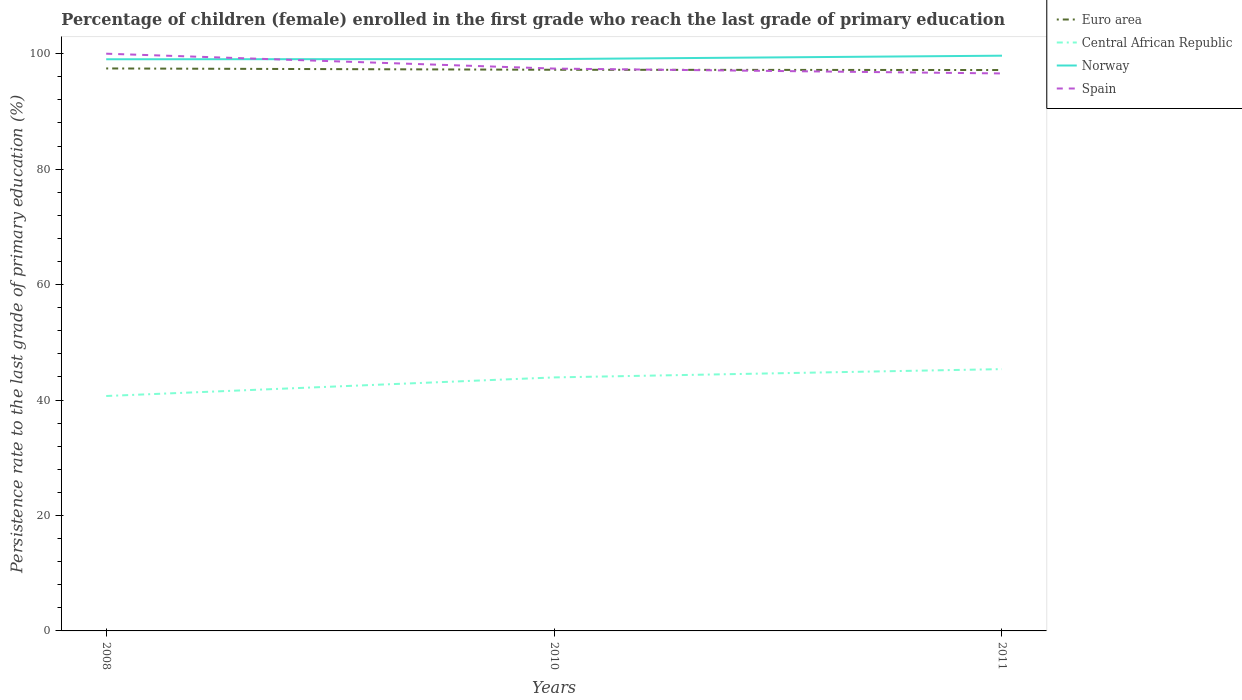How many different coloured lines are there?
Offer a terse response. 4. Across all years, what is the maximum persistence rate of children in Central African Republic?
Offer a terse response. 40.7. What is the total persistence rate of children in Spain in the graph?
Your response must be concise. 2.58. What is the difference between the highest and the second highest persistence rate of children in Norway?
Make the answer very short. 0.62. What is the difference between the highest and the lowest persistence rate of children in Spain?
Make the answer very short. 1. How many years are there in the graph?
Give a very brief answer. 3. What is the difference between two consecutive major ticks on the Y-axis?
Provide a short and direct response. 20. Does the graph contain any zero values?
Keep it short and to the point. No. Does the graph contain grids?
Offer a terse response. No. What is the title of the graph?
Give a very brief answer. Percentage of children (female) enrolled in the first grade who reach the last grade of primary education. What is the label or title of the Y-axis?
Make the answer very short. Persistence rate to the last grade of primary education (%). What is the Persistence rate to the last grade of primary education (%) in Euro area in 2008?
Your answer should be very brief. 97.44. What is the Persistence rate to the last grade of primary education (%) of Central African Republic in 2008?
Offer a terse response. 40.7. What is the Persistence rate to the last grade of primary education (%) of Norway in 2008?
Offer a terse response. 99.03. What is the Persistence rate to the last grade of primary education (%) in Spain in 2008?
Keep it short and to the point. 100. What is the Persistence rate to the last grade of primary education (%) in Euro area in 2010?
Keep it short and to the point. 97.21. What is the Persistence rate to the last grade of primary education (%) in Central African Republic in 2010?
Provide a short and direct response. 43.92. What is the Persistence rate to the last grade of primary education (%) in Norway in 2010?
Give a very brief answer. 99.07. What is the Persistence rate to the last grade of primary education (%) in Spain in 2010?
Give a very brief answer. 97.42. What is the Persistence rate to the last grade of primary education (%) of Euro area in 2011?
Your answer should be very brief. 97.17. What is the Persistence rate to the last grade of primary education (%) in Central African Republic in 2011?
Provide a succinct answer. 45.35. What is the Persistence rate to the last grade of primary education (%) in Norway in 2011?
Your answer should be very brief. 99.65. What is the Persistence rate to the last grade of primary education (%) in Spain in 2011?
Your answer should be very brief. 96.57. Across all years, what is the maximum Persistence rate to the last grade of primary education (%) in Euro area?
Keep it short and to the point. 97.44. Across all years, what is the maximum Persistence rate to the last grade of primary education (%) of Central African Republic?
Your answer should be very brief. 45.35. Across all years, what is the maximum Persistence rate to the last grade of primary education (%) in Norway?
Ensure brevity in your answer.  99.65. Across all years, what is the maximum Persistence rate to the last grade of primary education (%) of Spain?
Ensure brevity in your answer.  100. Across all years, what is the minimum Persistence rate to the last grade of primary education (%) of Euro area?
Ensure brevity in your answer.  97.17. Across all years, what is the minimum Persistence rate to the last grade of primary education (%) in Central African Republic?
Provide a succinct answer. 40.7. Across all years, what is the minimum Persistence rate to the last grade of primary education (%) of Norway?
Offer a very short reply. 99.03. Across all years, what is the minimum Persistence rate to the last grade of primary education (%) in Spain?
Offer a very short reply. 96.57. What is the total Persistence rate to the last grade of primary education (%) in Euro area in the graph?
Ensure brevity in your answer.  291.82. What is the total Persistence rate to the last grade of primary education (%) of Central African Republic in the graph?
Your response must be concise. 129.97. What is the total Persistence rate to the last grade of primary education (%) in Norway in the graph?
Your answer should be very brief. 297.75. What is the total Persistence rate to the last grade of primary education (%) in Spain in the graph?
Make the answer very short. 293.99. What is the difference between the Persistence rate to the last grade of primary education (%) in Euro area in 2008 and that in 2010?
Ensure brevity in your answer.  0.23. What is the difference between the Persistence rate to the last grade of primary education (%) in Central African Republic in 2008 and that in 2010?
Offer a very short reply. -3.22. What is the difference between the Persistence rate to the last grade of primary education (%) of Norway in 2008 and that in 2010?
Offer a terse response. -0.04. What is the difference between the Persistence rate to the last grade of primary education (%) of Spain in 2008 and that in 2010?
Give a very brief answer. 2.58. What is the difference between the Persistence rate to the last grade of primary education (%) of Euro area in 2008 and that in 2011?
Your answer should be very brief. 0.27. What is the difference between the Persistence rate to the last grade of primary education (%) in Central African Republic in 2008 and that in 2011?
Your answer should be compact. -4.66. What is the difference between the Persistence rate to the last grade of primary education (%) in Norway in 2008 and that in 2011?
Your response must be concise. -0.62. What is the difference between the Persistence rate to the last grade of primary education (%) of Spain in 2008 and that in 2011?
Offer a very short reply. 3.42. What is the difference between the Persistence rate to the last grade of primary education (%) in Euro area in 2010 and that in 2011?
Make the answer very short. 0.05. What is the difference between the Persistence rate to the last grade of primary education (%) of Central African Republic in 2010 and that in 2011?
Provide a short and direct response. -1.44. What is the difference between the Persistence rate to the last grade of primary education (%) in Norway in 2010 and that in 2011?
Your answer should be very brief. -0.58. What is the difference between the Persistence rate to the last grade of primary education (%) of Spain in 2010 and that in 2011?
Give a very brief answer. 0.84. What is the difference between the Persistence rate to the last grade of primary education (%) of Euro area in 2008 and the Persistence rate to the last grade of primary education (%) of Central African Republic in 2010?
Give a very brief answer. 53.52. What is the difference between the Persistence rate to the last grade of primary education (%) of Euro area in 2008 and the Persistence rate to the last grade of primary education (%) of Norway in 2010?
Ensure brevity in your answer.  -1.63. What is the difference between the Persistence rate to the last grade of primary education (%) of Euro area in 2008 and the Persistence rate to the last grade of primary education (%) of Spain in 2010?
Your answer should be very brief. 0.02. What is the difference between the Persistence rate to the last grade of primary education (%) of Central African Republic in 2008 and the Persistence rate to the last grade of primary education (%) of Norway in 2010?
Your answer should be compact. -58.37. What is the difference between the Persistence rate to the last grade of primary education (%) in Central African Republic in 2008 and the Persistence rate to the last grade of primary education (%) in Spain in 2010?
Keep it short and to the point. -56.72. What is the difference between the Persistence rate to the last grade of primary education (%) in Norway in 2008 and the Persistence rate to the last grade of primary education (%) in Spain in 2010?
Your response must be concise. 1.61. What is the difference between the Persistence rate to the last grade of primary education (%) of Euro area in 2008 and the Persistence rate to the last grade of primary education (%) of Central African Republic in 2011?
Your response must be concise. 52.09. What is the difference between the Persistence rate to the last grade of primary education (%) in Euro area in 2008 and the Persistence rate to the last grade of primary education (%) in Norway in 2011?
Offer a terse response. -2.21. What is the difference between the Persistence rate to the last grade of primary education (%) in Euro area in 2008 and the Persistence rate to the last grade of primary education (%) in Spain in 2011?
Your answer should be very brief. 0.87. What is the difference between the Persistence rate to the last grade of primary education (%) of Central African Republic in 2008 and the Persistence rate to the last grade of primary education (%) of Norway in 2011?
Ensure brevity in your answer.  -58.96. What is the difference between the Persistence rate to the last grade of primary education (%) of Central African Republic in 2008 and the Persistence rate to the last grade of primary education (%) of Spain in 2011?
Ensure brevity in your answer.  -55.88. What is the difference between the Persistence rate to the last grade of primary education (%) of Norway in 2008 and the Persistence rate to the last grade of primary education (%) of Spain in 2011?
Give a very brief answer. 2.46. What is the difference between the Persistence rate to the last grade of primary education (%) of Euro area in 2010 and the Persistence rate to the last grade of primary education (%) of Central African Republic in 2011?
Offer a terse response. 51.86. What is the difference between the Persistence rate to the last grade of primary education (%) in Euro area in 2010 and the Persistence rate to the last grade of primary education (%) in Norway in 2011?
Ensure brevity in your answer.  -2.44. What is the difference between the Persistence rate to the last grade of primary education (%) of Euro area in 2010 and the Persistence rate to the last grade of primary education (%) of Spain in 2011?
Keep it short and to the point. 0.64. What is the difference between the Persistence rate to the last grade of primary education (%) of Central African Republic in 2010 and the Persistence rate to the last grade of primary education (%) of Norway in 2011?
Provide a short and direct response. -55.73. What is the difference between the Persistence rate to the last grade of primary education (%) of Central African Republic in 2010 and the Persistence rate to the last grade of primary education (%) of Spain in 2011?
Provide a succinct answer. -52.66. What is the difference between the Persistence rate to the last grade of primary education (%) of Norway in 2010 and the Persistence rate to the last grade of primary education (%) of Spain in 2011?
Give a very brief answer. 2.49. What is the average Persistence rate to the last grade of primary education (%) of Euro area per year?
Offer a terse response. 97.27. What is the average Persistence rate to the last grade of primary education (%) in Central African Republic per year?
Offer a very short reply. 43.32. What is the average Persistence rate to the last grade of primary education (%) in Norway per year?
Provide a short and direct response. 99.25. What is the average Persistence rate to the last grade of primary education (%) in Spain per year?
Offer a very short reply. 98. In the year 2008, what is the difference between the Persistence rate to the last grade of primary education (%) in Euro area and Persistence rate to the last grade of primary education (%) in Central African Republic?
Keep it short and to the point. 56.74. In the year 2008, what is the difference between the Persistence rate to the last grade of primary education (%) in Euro area and Persistence rate to the last grade of primary education (%) in Norway?
Your answer should be very brief. -1.59. In the year 2008, what is the difference between the Persistence rate to the last grade of primary education (%) of Euro area and Persistence rate to the last grade of primary education (%) of Spain?
Offer a very short reply. -2.56. In the year 2008, what is the difference between the Persistence rate to the last grade of primary education (%) of Central African Republic and Persistence rate to the last grade of primary education (%) of Norway?
Offer a very short reply. -58.34. In the year 2008, what is the difference between the Persistence rate to the last grade of primary education (%) in Central African Republic and Persistence rate to the last grade of primary education (%) in Spain?
Provide a short and direct response. -59.3. In the year 2008, what is the difference between the Persistence rate to the last grade of primary education (%) of Norway and Persistence rate to the last grade of primary education (%) of Spain?
Your response must be concise. -0.97. In the year 2010, what is the difference between the Persistence rate to the last grade of primary education (%) in Euro area and Persistence rate to the last grade of primary education (%) in Central African Republic?
Ensure brevity in your answer.  53.3. In the year 2010, what is the difference between the Persistence rate to the last grade of primary education (%) in Euro area and Persistence rate to the last grade of primary education (%) in Norway?
Provide a short and direct response. -1.85. In the year 2010, what is the difference between the Persistence rate to the last grade of primary education (%) of Euro area and Persistence rate to the last grade of primary education (%) of Spain?
Your answer should be compact. -0.21. In the year 2010, what is the difference between the Persistence rate to the last grade of primary education (%) of Central African Republic and Persistence rate to the last grade of primary education (%) of Norway?
Provide a short and direct response. -55.15. In the year 2010, what is the difference between the Persistence rate to the last grade of primary education (%) in Central African Republic and Persistence rate to the last grade of primary education (%) in Spain?
Make the answer very short. -53.5. In the year 2010, what is the difference between the Persistence rate to the last grade of primary education (%) in Norway and Persistence rate to the last grade of primary education (%) in Spain?
Ensure brevity in your answer.  1.65. In the year 2011, what is the difference between the Persistence rate to the last grade of primary education (%) of Euro area and Persistence rate to the last grade of primary education (%) of Central African Republic?
Give a very brief answer. 51.81. In the year 2011, what is the difference between the Persistence rate to the last grade of primary education (%) of Euro area and Persistence rate to the last grade of primary education (%) of Norway?
Provide a succinct answer. -2.48. In the year 2011, what is the difference between the Persistence rate to the last grade of primary education (%) of Euro area and Persistence rate to the last grade of primary education (%) of Spain?
Your answer should be very brief. 0.59. In the year 2011, what is the difference between the Persistence rate to the last grade of primary education (%) of Central African Republic and Persistence rate to the last grade of primary education (%) of Norway?
Make the answer very short. -54.3. In the year 2011, what is the difference between the Persistence rate to the last grade of primary education (%) of Central African Republic and Persistence rate to the last grade of primary education (%) of Spain?
Ensure brevity in your answer.  -51.22. In the year 2011, what is the difference between the Persistence rate to the last grade of primary education (%) in Norway and Persistence rate to the last grade of primary education (%) in Spain?
Give a very brief answer. 3.08. What is the ratio of the Persistence rate to the last grade of primary education (%) of Central African Republic in 2008 to that in 2010?
Your answer should be very brief. 0.93. What is the ratio of the Persistence rate to the last grade of primary education (%) of Spain in 2008 to that in 2010?
Your answer should be compact. 1.03. What is the ratio of the Persistence rate to the last grade of primary education (%) of Euro area in 2008 to that in 2011?
Ensure brevity in your answer.  1. What is the ratio of the Persistence rate to the last grade of primary education (%) in Central African Republic in 2008 to that in 2011?
Give a very brief answer. 0.9. What is the ratio of the Persistence rate to the last grade of primary education (%) of Norway in 2008 to that in 2011?
Ensure brevity in your answer.  0.99. What is the ratio of the Persistence rate to the last grade of primary education (%) of Spain in 2008 to that in 2011?
Provide a short and direct response. 1.04. What is the ratio of the Persistence rate to the last grade of primary education (%) in Central African Republic in 2010 to that in 2011?
Ensure brevity in your answer.  0.97. What is the ratio of the Persistence rate to the last grade of primary education (%) in Norway in 2010 to that in 2011?
Provide a short and direct response. 0.99. What is the ratio of the Persistence rate to the last grade of primary education (%) in Spain in 2010 to that in 2011?
Give a very brief answer. 1.01. What is the difference between the highest and the second highest Persistence rate to the last grade of primary education (%) in Euro area?
Provide a succinct answer. 0.23. What is the difference between the highest and the second highest Persistence rate to the last grade of primary education (%) of Central African Republic?
Offer a very short reply. 1.44. What is the difference between the highest and the second highest Persistence rate to the last grade of primary education (%) of Norway?
Ensure brevity in your answer.  0.58. What is the difference between the highest and the second highest Persistence rate to the last grade of primary education (%) in Spain?
Provide a succinct answer. 2.58. What is the difference between the highest and the lowest Persistence rate to the last grade of primary education (%) of Euro area?
Your answer should be compact. 0.27. What is the difference between the highest and the lowest Persistence rate to the last grade of primary education (%) of Central African Republic?
Make the answer very short. 4.66. What is the difference between the highest and the lowest Persistence rate to the last grade of primary education (%) of Norway?
Make the answer very short. 0.62. What is the difference between the highest and the lowest Persistence rate to the last grade of primary education (%) of Spain?
Provide a short and direct response. 3.42. 